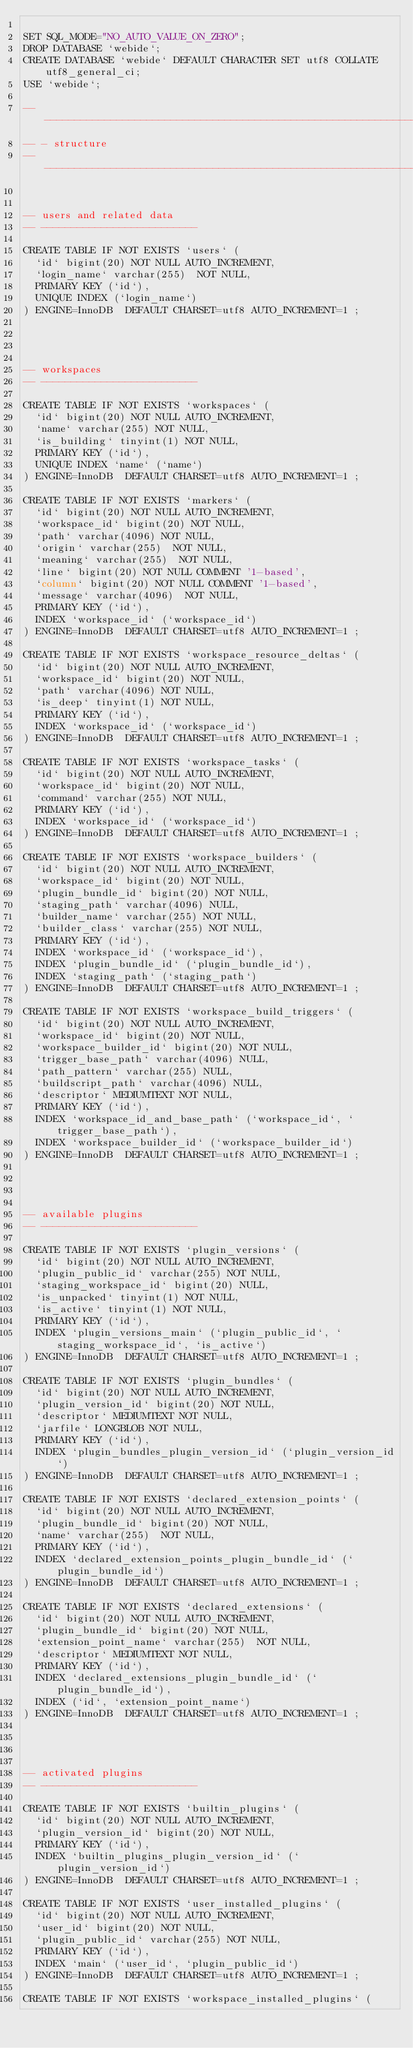Convert code to text. <code><loc_0><loc_0><loc_500><loc_500><_SQL_>
SET SQL_MODE="NO_AUTO_VALUE_ON_ZERO";
DROP DATABASE `webide`;
CREATE DATABASE `webide` DEFAULT CHARACTER SET utf8 COLLATE utf8_general_ci;
USE `webide`;

-- -------------------------------------------------------------------------
-- - structure
-- -------------------------------------------------------------------------


-- users and related data
-- --------------------------

CREATE TABLE IF NOT EXISTS `users` (
  `id` bigint(20) NOT NULL AUTO_INCREMENT,
  `login_name` varchar(255)  NOT NULL,
  PRIMARY KEY (`id`),
  UNIQUE INDEX (`login_name`)
) ENGINE=InnoDB  DEFAULT CHARSET=utf8 AUTO_INCREMENT=1 ;




-- workspaces
-- --------------------------

CREATE TABLE IF NOT EXISTS `workspaces` (
  `id` bigint(20) NOT NULL AUTO_INCREMENT,
  `name` varchar(255) NOT NULL,
  `is_building` tinyint(1) NOT NULL,
  PRIMARY KEY (`id`),
  UNIQUE INDEX `name` (`name`)
) ENGINE=InnoDB  DEFAULT CHARSET=utf8 AUTO_INCREMENT=1 ;

CREATE TABLE IF NOT EXISTS `markers` (
  `id` bigint(20) NOT NULL AUTO_INCREMENT,
  `workspace_id` bigint(20) NOT NULL,
  `path` varchar(4096) NOT NULL,
  `origin` varchar(255)  NOT NULL,
  `meaning` varchar(255)  NOT NULL,
  `line` bigint(20) NOT NULL COMMENT '1-based',
  `column` bigint(20) NOT NULL COMMENT '1-based',
  `message` varchar(4096)  NOT NULL,
  PRIMARY KEY (`id`),
  INDEX `workspace_id` (`workspace_id`)
) ENGINE=InnoDB  DEFAULT CHARSET=utf8 AUTO_INCREMENT=1 ;

CREATE TABLE IF NOT EXISTS `workspace_resource_deltas` (
  `id` bigint(20) NOT NULL AUTO_INCREMENT,
  `workspace_id` bigint(20) NOT NULL,
  `path` varchar(4096) NOT NULL,
  `is_deep` tinyint(1) NOT NULL,
  PRIMARY KEY (`id`),
  INDEX `workspace_id` (`workspace_id`)
) ENGINE=InnoDB  DEFAULT CHARSET=utf8 AUTO_INCREMENT=1 ;

CREATE TABLE IF NOT EXISTS `workspace_tasks` (
  `id` bigint(20) NOT NULL AUTO_INCREMENT,
  `workspace_id` bigint(20) NOT NULL,
  `command` varchar(255) NOT NULL,
  PRIMARY KEY (`id`),
  INDEX `workspace_id` (`workspace_id`)
) ENGINE=InnoDB  DEFAULT CHARSET=utf8 AUTO_INCREMENT=1 ;

CREATE TABLE IF NOT EXISTS `workspace_builders` (
  `id` bigint(20) NOT NULL AUTO_INCREMENT,
  `workspace_id` bigint(20) NOT NULL,
  `plugin_bundle_id` bigint(20) NOT NULL,
  `staging_path` varchar(4096) NULL,
  `builder_name` varchar(255) NOT NULL,
  `builder_class` varchar(255) NOT NULL,
  PRIMARY KEY (`id`),
  INDEX `workspace_id` (`workspace_id`),
  INDEX `plugin_bundle_id` (`plugin_bundle_id`),
  INDEX `staging_path` (`staging_path`)
) ENGINE=InnoDB  DEFAULT CHARSET=utf8 AUTO_INCREMENT=1 ;

CREATE TABLE IF NOT EXISTS `workspace_build_triggers` (
  `id` bigint(20) NOT NULL AUTO_INCREMENT,
  `workspace_id` bigint(20) NOT NULL,
  `workspace_builder_id` bigint(20) NOT NULL,
  `trigger_base_path` varchar(4096) NULL,
  `path_pattern` varchar(255) NULL,
  `buildscript_path` varchar(4096) NULL,
  `descriptor` MEDIUMTEXT NOT NULL,
  PRIMARY KEY (`id`),
  INDEX `workspace_id_and_base_path` (`workspace_id`, `trigger_base_path`),
  INDEX `workspace_builder_id` (`workspace_builder_id`)
) ENGINE=InnoDB  DEFAULT CHARSET=utf8 AUTO_INCREMENT=1 ;




-- available plugins
-- --------------------------

CREATE TABLE IF NOT EXISTS `plugin_versions` (
  `id` bigint(20) NOT NULL AUTO_INCREMENT,
  `plugin_public_id` varchar(255) NOT NULL,
  `staging_workspace_id` bigint(20) NULL,
  `is_unpacked` tinyint(1) NOT NULL,
  `is_active` tinyint(1) NOT NULL,
  PRIMARY KEY (`id`),
  INDEX `plugin_versions_main` (`plugin_public_id`, `staging_workspace_id`, `is_active`)
) ENGINE=InnoDB  DEFAULT CHARSET=utf8 AUTO_INCREMENT=1 ;

CREATE TABLE IF NOT EXISTS `plugin_bundles` (
  `id` bigint(20) NOT NULL AUTO_INCREMENT,
  `plugin_version_id` bigint(20) NOT NULL,
  `descriptor` MEDIUMTEXT NOT NULL,
  `jarfile` LONGBLOB NOT NULL,
  PRIMARY KEY (`id`),
  INDEX `plugin_bundles_plugin_version_id` (`plugin_version_id`)
) ENGINE=InnoDB  DEFAULT CHARSET=utf8 AUTO_INCREMENT=1 ;

CREATE TABLE IF NOT EXISTS `declared_extension_points` (
  `id` bigint(20) NOT NULL AUTO_INCREMENT,
  `plugin_bundle_id` bigint(20) NOT NULL,
  `name` varchar(255)  NOT NULL,
  PRIMARY KEY (`id`),
  INDEX `declared_extension_points_plugin_bundle_id` (`plugin_bundle_id`)
) ENGINE=InnoDB  DEFAULT CHARSET=utf8 AUTO_INCREMENT=1 ;

CREATE TABLE IF NOT EXISTS `declared_extensions` (
  `id` bigint(20) NOT NULL AUTO_INCREMENT,
  `plugin_bundle_id` bigint(20) NOT NULL,
  `extension_point_name` varchar(255)  NOT NULL,
  `descriptor` MEDIUMTEXT NOT NULL,
  PRIMARY KEY (`id`),
  INDEX `declared_extensions_plugin_bundle_id` (`plugin_bundle_id`),
  INDEX (`id`, `extension_point_name`)
) ENGINE=InnoDB  DEFAULT CHARSET=utf8 AUTO_INCREMENT=1 ;




-- activated plugins
-- --------------------------

CREATE TABLE IF NOT EXISTS `builtin_plugins` (
  `id` bigint(20) NOT NULL AUTO_INCREMENT,
  `plugin_version_id` bigint(20) NOT NULL,
  PRIMARY KEY (`id`),
  INDEX `builtin_plugins_plugin_version_id` (`plugin_version_id`)
) ENGINE=InnoDB  DEFAULT CHARSET=utf8 AUTO_INCREMENT=1 ;

CREATE TABLE IF NOT EXISTS `user_installed_plugins` (
  `id` bigint(20) NOT NULL AUTO_INCREMENT,
  `user_id` bigint(20) NOT NULL,
  `plugin_public_id` varchar(255) NOT NULL,
  PRIMARY KEY (`id`),
  INDEX `main` (`user_id`, `plugin_public_id`)
) ENGINE=InnoDB  DEFAULT CHARSET=utf8 AUTO_INCREMENT=1 ;

CREATE TABLE IF NOT EXISTS `workspace_installed_plugins` (</code> 